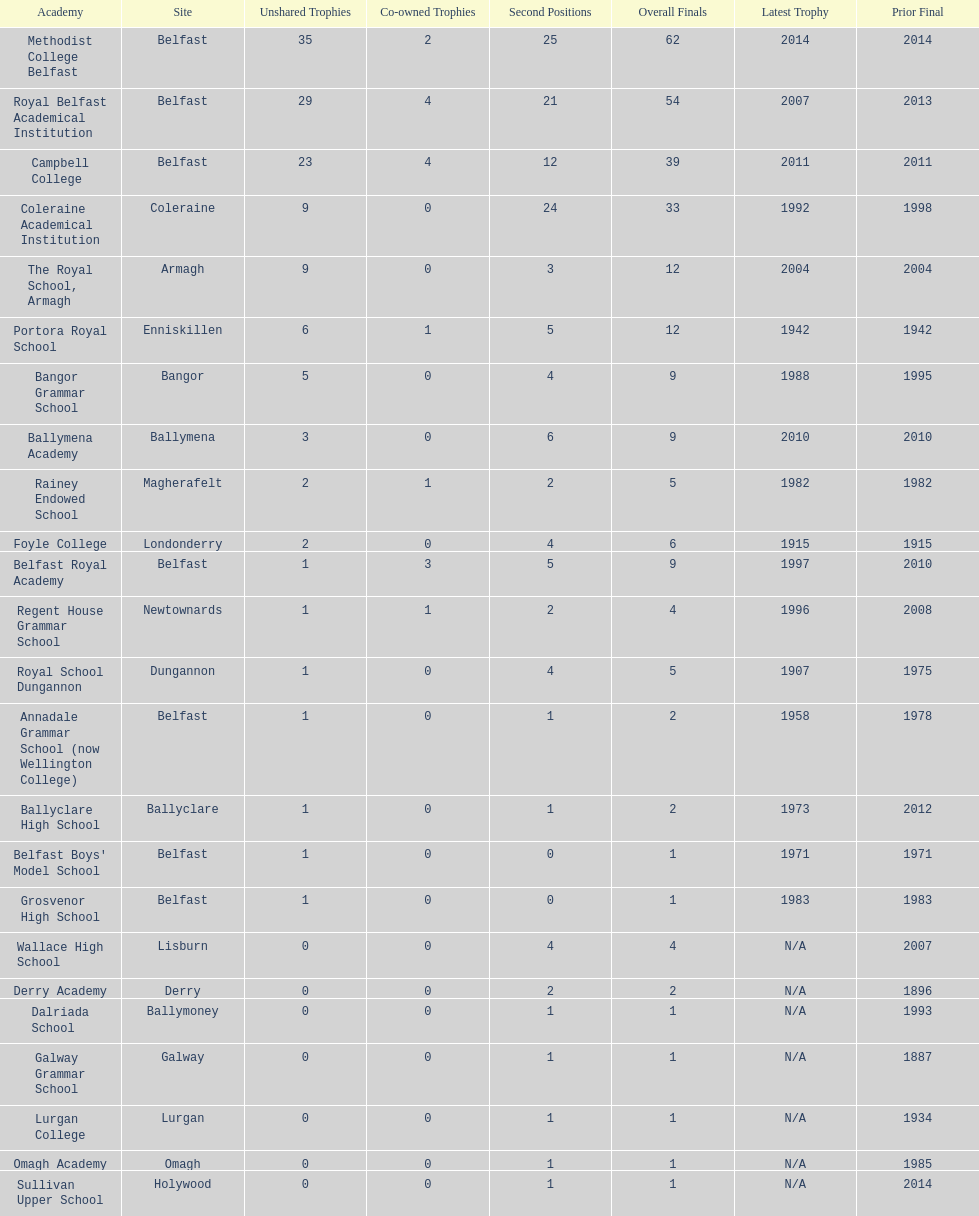Which two schools each had twelve total finals? The Royal School, Armagh, Portora Royal School. 